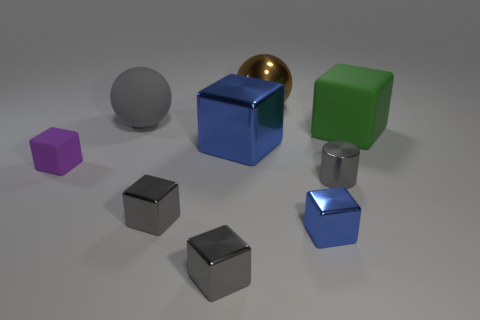Are there any red metal blocks that have the same size as the green block?
Your answer should be compact. No. What is the color of the big sphere on the left side of the big shiny ball?
Give a very brief answer. Gray. What shape is the tiny object that is on the left side of the cylinder and on the right side of the metal sphere?
Offer a very short reply. Cube. How many brown metallic things are the same shape as the purple thing?
Your answer should be compact. 0. How many gray matte spheres are there?
Give a very brief answer. 1. There is a shiny object that is both behind the gray cylinder and in front of the green cube; what is its size?
Provide a short and direct response. Large. What is the shape of the gray matte thing that is the same size as the green object?
Offer a terse response. Sphere. Is there a large blue metallic block on the right side of the big matte object that is right of the metal cylinder?
Offer a terse response. No. What is the color of the other rubber object that is the same shape as the large green object?
Your answer should be compact. Purple. There is a big metallic object that is in front of the big green block; is it the same color as the big shiny sphere?
Give a very brief answer. No. 